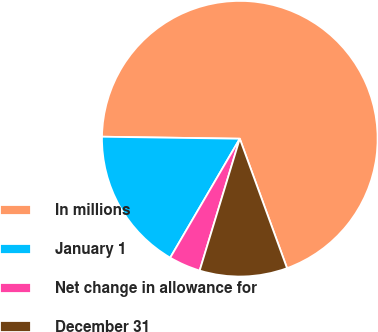<chart> <loc_0><loc_0><loc_500><loc_500><pie_chart><fcel>In millions<fcel>January 1<fcel>Net change in allowance for<fcel>December 31<nl><fcel>69.2%<fcel>16.81%<fcel>3.72%<fcel>10.27%<nl></chart> 